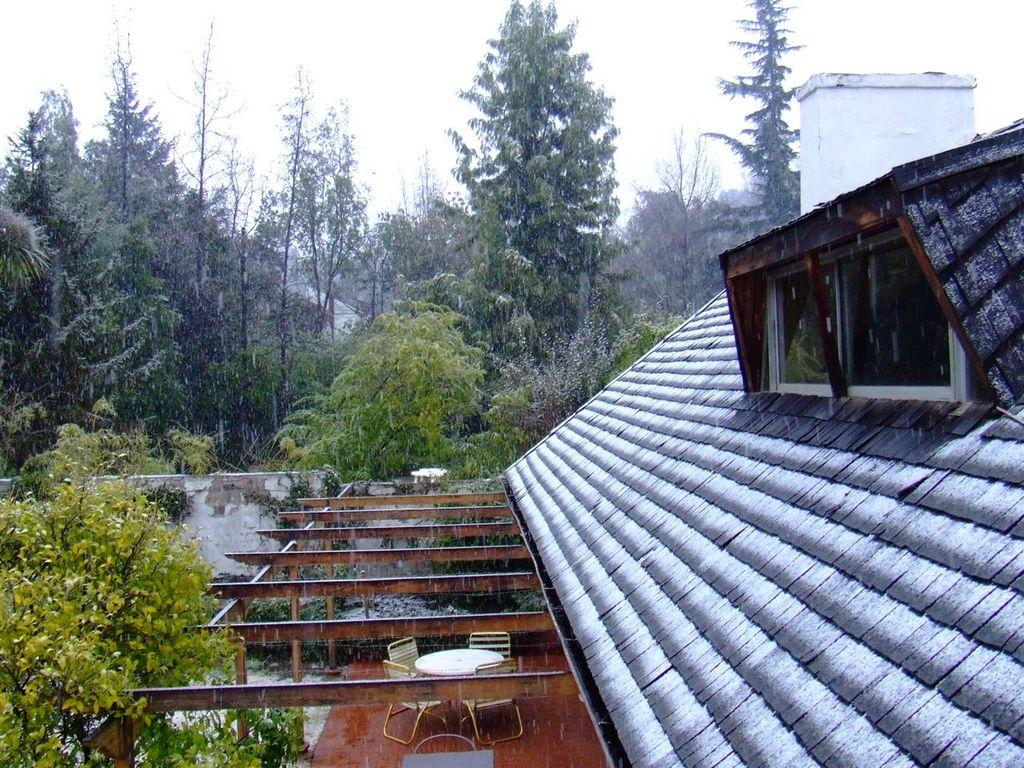What type of structure is visible in the image? The roof of a house is visible in the image. What architectural features can be seen on the house? There are windows in the image. What type of furniture is present in the image? Chairs are present in the image. What type of surface is visible in the image? A table is visible in the image. What type of natural elements are present in the image? Trees and plants are visible in the image. What part of the natural environment is visible in the image? The sky is visible in the image. How many rabbits are hopping around on the canvas in the image? There are no rabbits or canvas present in the image. What type of party is being held in the image? There is no party depicted in the image. 